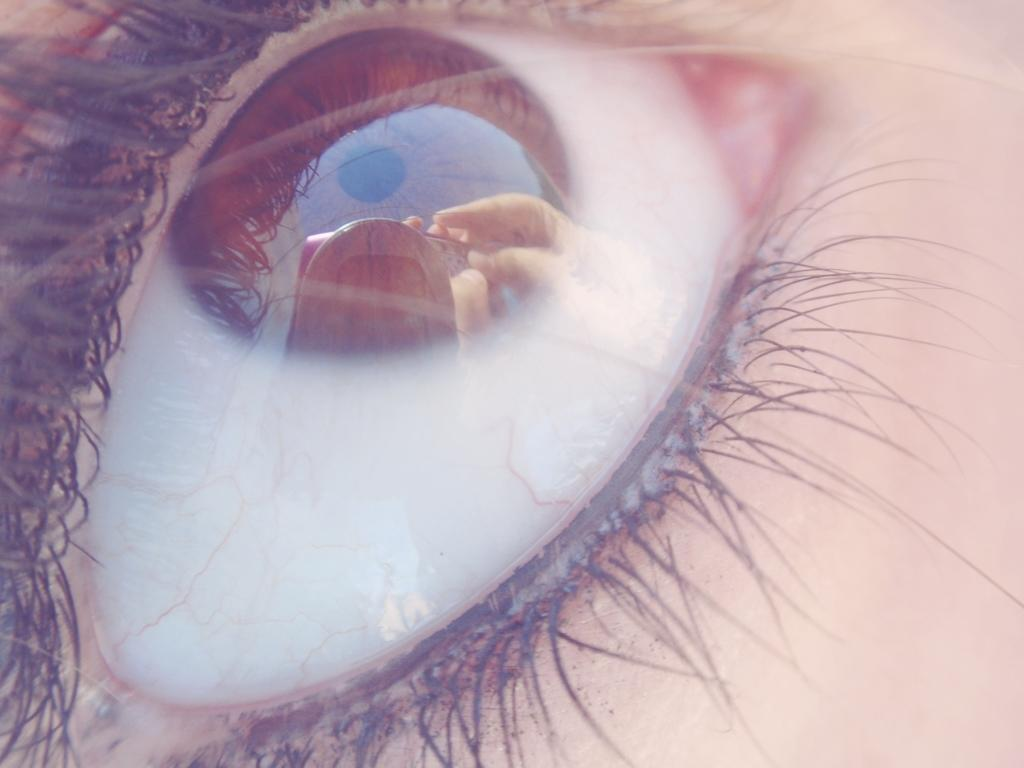What is the main subject of the image? The main subject of the image is a person's eye. What can be observed within the eye in the image? There are reflections visible in the eyelid. What type of mint plant can be seen growing in the image? There is no mint plant present in the image; it features a person's eye with reflections visible in the eyelid. How many pets are visible in the image? There are no pets present in the image. 